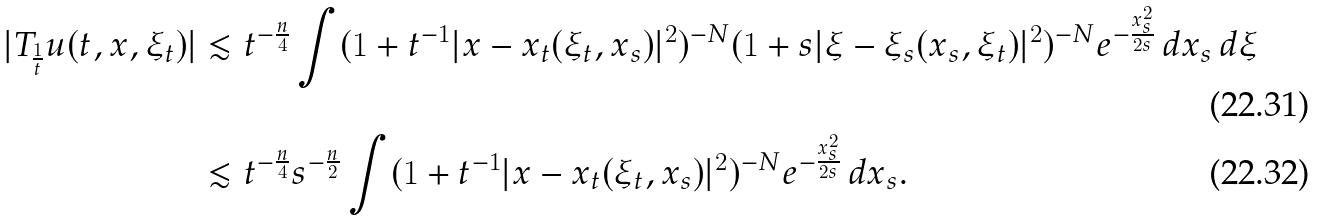Convert formula to latex. <formula><loc_0><loc_0><loc_500><loc_500>| T _ { \frac { 1 } { t } } u ( t , x , \xi _ { t } ) | & \lesssim t ^ { - \frac { n } { 4 } } \int ( 1 + t ^ { - 1 } | x - x _ { t } ( \xi _ { t } , x _ { s } ) | ^ { 2 } ) ^ { - N } ( 1 + s | \xi - \xi _ { s } ( x _ { s } , \xi _ { t } ) | ^ { 2 } ) ^ { - N } e ^ { - \frac { x _ { s } ^ { 2 } } { 2 s } } \, d x _ { s } \, d \xi \\ & \lesssim t ^ { - \frac { n } { 4 } } s ^ { - \frac { n } { 2 } } \int ( 1 + t ^ { - 1 } | x - x _ { t } ( \xi _ { t } , x _ { s } ) | ^ { 2 } ) ^ { - N } e ^ { - \frac { x _ { s } ^ { 2 } } { 2 s } } \, d x _ { s } .</formula> 